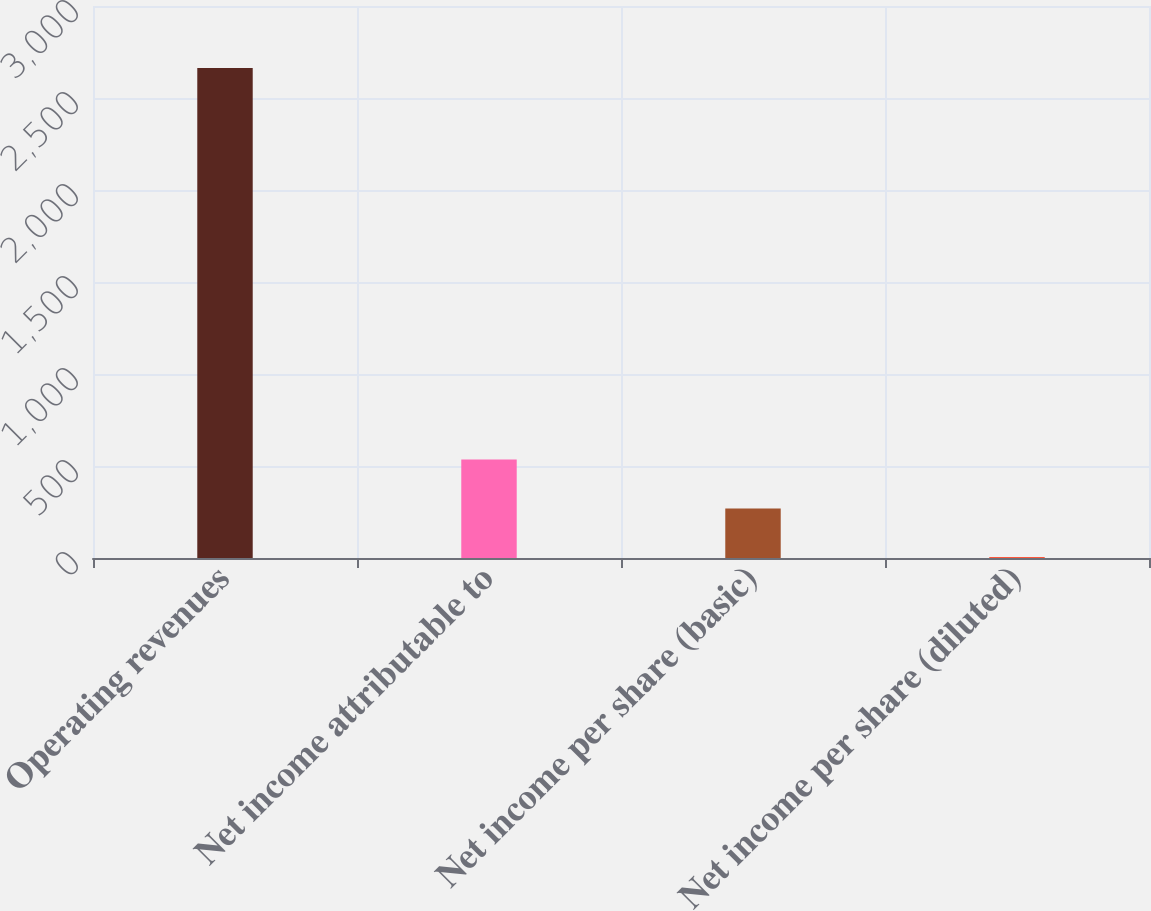Convert chart. <chart><loc_0><loc_0><loc_500><loc_500><bar_chart><fcel>Operating revenues<fcel>Net income attributable to<fcel>Net income per share (basic)<fcel>Net income per share (diluted)<nl><fcel>2663.6<fcel>535.57<fcel>269.56<fcel>3.55<nl></chart> 